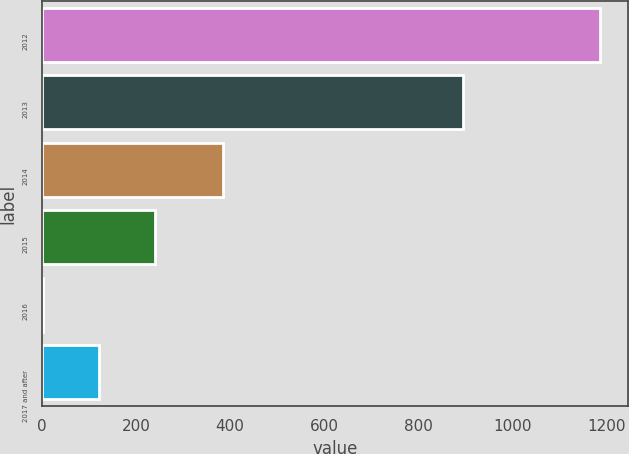Convert chart to OTSL. <chart><loc_0><loc_0><loc_500><loc_500><bar_chart><fcel>2012<fcel>2013<fcel>2014<fcel>2015<fcel>2016<fcel>2017 and after<nl><fcel>1186<fcel>895<fcel>386<fcel>239.6<fcel>3<fcel>121.3<nl></chart> 